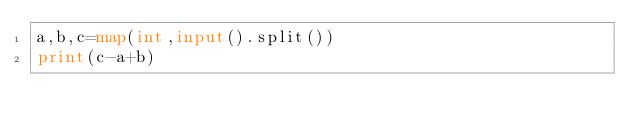Convert code to text. <code><loc_0><loc_0><loc_500><loc_500><_Python_>a,b,c=map(int,input().split())
print(c-a+b)</code> 